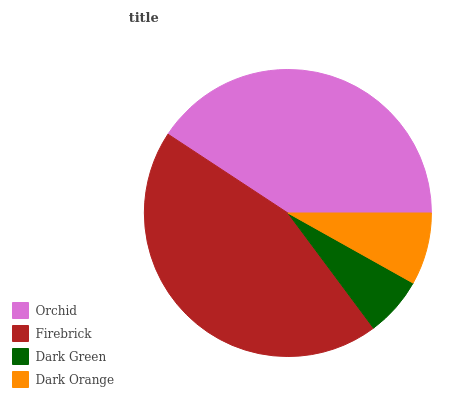Is Dark Green the minimum?
Answer yes or no. Yes. Is Firebrick the maximum?
Answer yes or no. Yes. Is Firebrick the minimum?
Answer yes or no. No. Is Dark Green the maximum?
Answer yes or no. No. Is Firebrick greater than Dark Green?
Answer yes or no. Yes. Is Dark Green less than Firebrick?
Answer yes or no. Yes. Is Dark Green greater than Firebrick?
Answer yes or no. No. Is Firebrick less than Dark Green?
Answer yes or no. No. Is Orchid the high median?
Answer yes or no. Yes. Is Dark Orange the low median?
Answer yes or no. Yes. Is Firebrick the high median?
Answer yes or no. No. Is Orchid the low median?
Answer yes or no. No. 